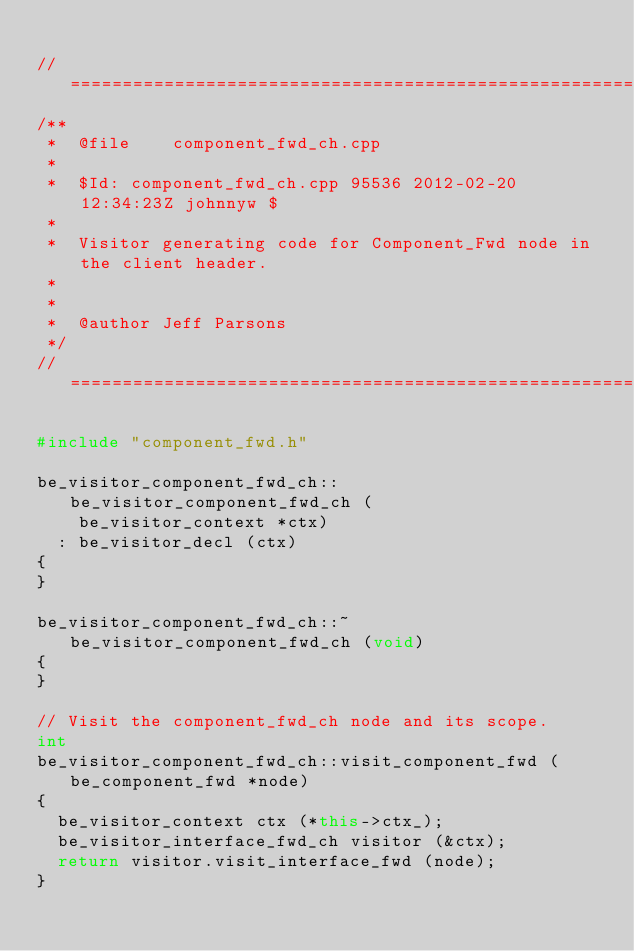Convert code to text. <code><loc_0><loc_0><loc_500><loc_500><_C++_>
//=============================================================================
/**
 *  @file    component_fwd_ch.cpp
 *
 *  $Id: component_fwd_ch.cpp 95536 2012-02-20 12:34:23Z johnnyw $
 *
 *  Visitor generating code for Component_Fwd node in the client header.
 *
 *
 *  @author Jeff Parsons
 */
//=============================================================================

#include "component_fwd.h"

be_visitor_component_fwd_ch::be_visitor_component_fwd_ch (
    be_visitor_context *ctx)
  : be_visitor_decl (ctx)
{
}

be_visitor_component_fwd_ch::~be_visitor_component_fwd_ch (void)
{
}

// Visit the component_fwd_ch node and its scope.
int
be_visitor_component_fwd_ch::visit_component_fwd (be_component_fwd *node)
{
  be_visitor_context ctx (*this->ctx_);
  be_visitor_interface_fwd_ch visitor (&ctx);
  return visitor.visit_interface_fwd (node);
}
</code> 